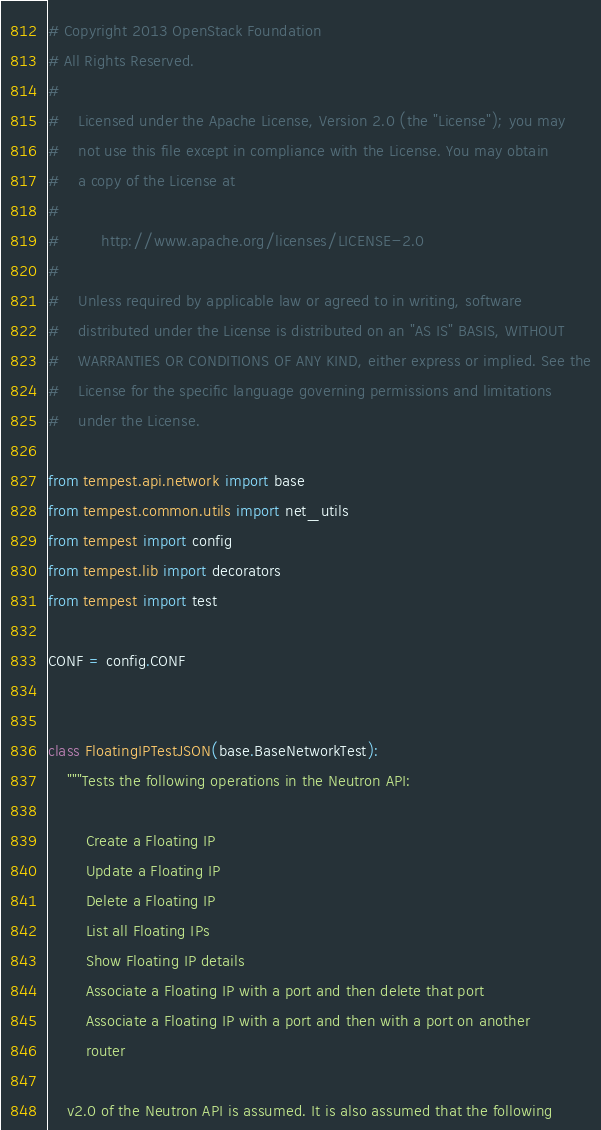Convert code to text. <code><loc_0><loc_0><loc_500><loc_500><_Python_># Copyright 2013 OpenStack Foundation
# All Rights Reserved.
#
#    Licensed under the Apache License, Version 2.0 (the "License"); you may
#    not use this file except in compliance with the License. You may obtain
#    a copy of the License at
#
#         http://www.apache.org/licenses/LICENSE-2.0
#
#    Unless required by applicable law or agreed to in writing, software
#    distributed under the License is distributed on an "AS IS" BASIS, WITHOUT
#    WARRANTIES OR CONDITIONS OF ANY KIND, either express or implied. See the
#    License for the specific language governing permissions and limitations
#    under the License.

from tempest.api.network import base
from tempest.common.utils import net_utils
from tempest import config
from tempest.lib import decorators
from tempest import test

CONF = config.CONF


class FloatingIPTestJSON(base.BaseNetworkTest):
    """Tests the following operations in the Neutron API:

        Create a Floating IP
        Update a Floating IP
        Delete a Floating IP
        List all Floating IPs
        Show Floating IP details
        Associate a Floating IP with a port and then delete that port
        Associate a Floating IP with a port and then with a port on another
        router

    v2.0 of the Neutron API is assumed. It is also assumed that the following</code> 